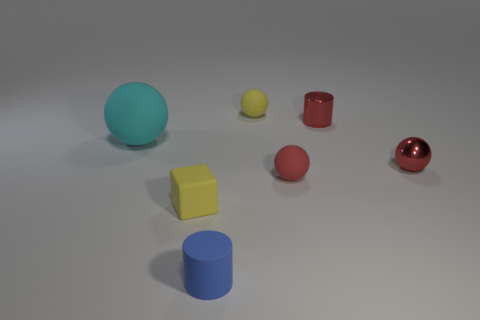Add 1 big green blocks. How many objects exist? 8 Subtract all yellow matte balls. How many balls are left? 3 Subtract all blue cylinders. How many cylinders are left? 1 Subtract all red spheres. Subtract all gray cylinders. How many spheres are left? 2 Subtract all cyan cubes. How many gray spheres are left? 0 Subtract all cylinders. How many objects are left? 5 Subtract all small yellow blocks. Subtract all small red metal spheres. How many objects are left? 5 Add 7 tiny metal things. How many tiny metal things are left? 9 Add 5 large red balls. How many large red balls exist? 5 Subtract 0 gray spheres. How many objects are left? 7 